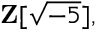<formula> <loc_0><loc_0><loc_500><loc_500>Z [ { \sqrt { - 5 } } ] ,</formula> 